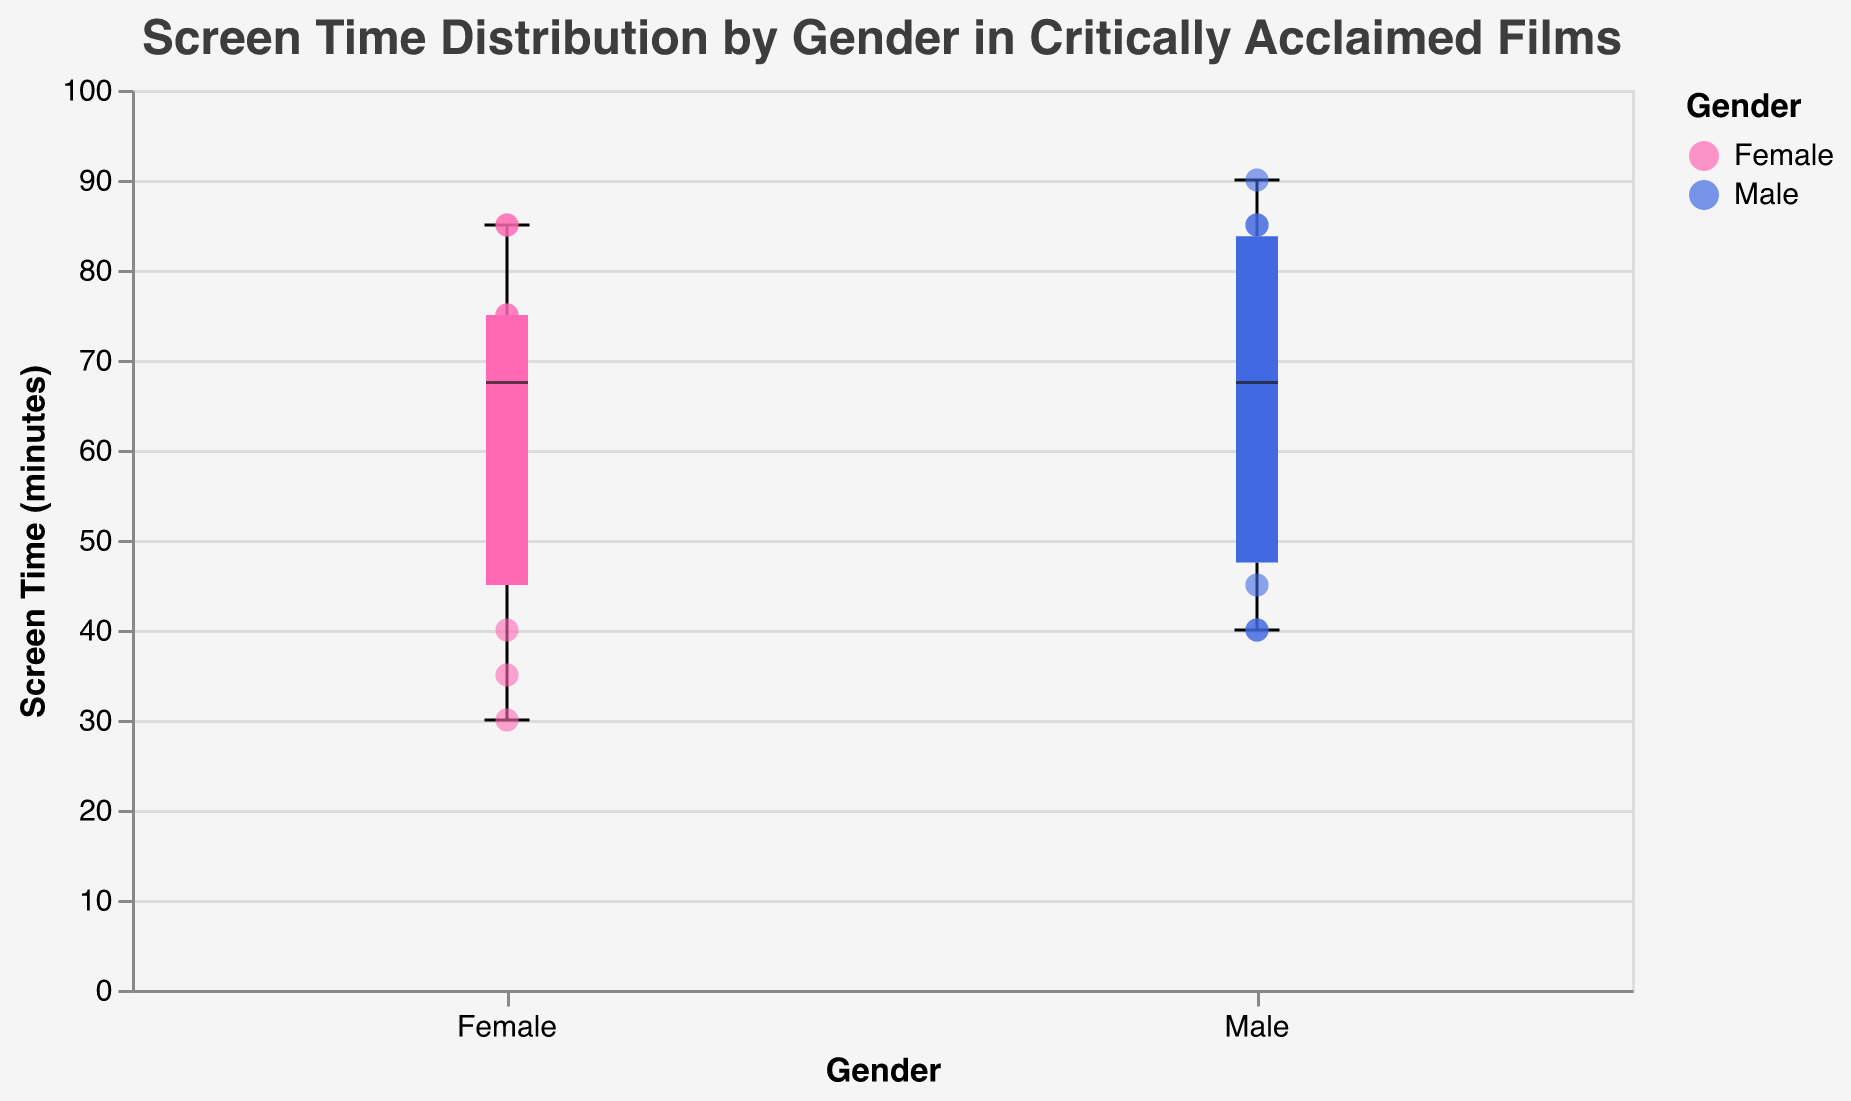What is the title of the chart? The title is displayed at the top of the chart. It reads, "Screen Time Distribution by Gender in Critically Acclaimed Films."
Answer: Screen Time Distribution by Gender in Critically Acclaimed Films Which gender has the highest median screen time? The box plot shows the median screen time as the thick line within each box. The median for females is higher than that for males.
Answer: Female What is the range of screen times for males? The range is the difference between the maximum and minimum screen times for males. The box plot and scatter points indicate a minimum of 40 minutes and a maximum of 90 minutes for males.
Answer: 50 minutes How many films are there where females have more screen time than males? By examining the scatter points, we can count the films where the female screen time value is higher than the male screen time value. The films are "The Shape of Water," "Roma," "Mad Max: Fury Road," "The Favourite," and "Lady Bird."
Answer: 5 films What is the interquartile range (IQR) for males? The IQR is the difference between the 75th percentile (upper hinge) and the 25th percentile (lower hinge) in the box plot. For males, the IQR spans from approximately 55 to 85 minutes.
Answer: 30 minutes Which film shows the largest difference in screen time between genders? Identifying the largest difference involves comparing the screen times for males and females across all films. "The Favourite" and "Roma" both have a difference of 45 minutes and are the largest observed differences.
Answer: The Favourite and Roma What is the minimum screen time recorded for females? The minimum value for females is the lowest point in the box plot with scatter points. The minimum screen time for females is 30 minutes.
Answer: 30 minutes Is there a film where the screen time for both genders is equal? By inspecting the scatter points, we can determine if there's any film with equal screen times for males and females. No such film is present in this dataset.
Answer: No Which film has the highest critical acclaim score and what are their screen times for both genders? The scatter points provide tooltip information, including the critical acclaim score. "Moonlight" has the highest score of 99, with males having 85 minutes and females 35 minutes of screen time.
Answer: Moonlight - 85 minutes (Male), 35 minutes (Female) What is the median screen time for females? The median screen time is represented by the thick line within the box for females. It is approximately 75 minutes.
Answer: 75 minutes 